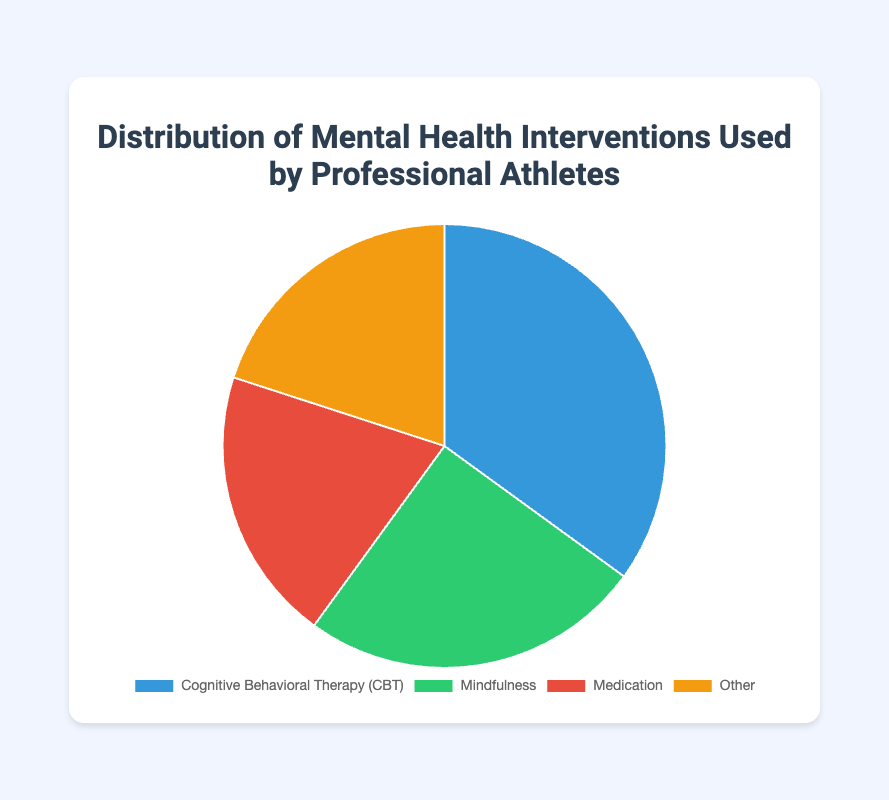Which mental health intervention is utilized the most by professional athletes? By looking at the pie chart, the Cognitive Behavioral Therapy (CBT) has the largest segment, representing the highest percentage of 35%.
Answer: Cognitive Behavioral Therapy (CBT) What percentage of mental health interventions are non-medication based? To find the non-medication-based interventions, sum the percentages of CBT (35%), Mindfulness (25%), and Other (20%): 35% + 25% + 20% = 80%.
Answer: 80% How does the usage of Medication compare to Other interventions? Both Medication and Other interventions each have a percentage of 20%. This means the usage of Medication is equal to Other interventions as per the pie chart.
Answer: Equal Which interventions combined constitute more than 50% of the total interventions? Adding the percentages of Cognitive Behavioral Therapy (CBT) at 35% and Mindfulness at 25% gives 35% + 25% = 60%, which is greater than 50%.
Answer: Cognitive Behavioral Therapy (CBT) and Mindfulness By what percentage does Mindfulness exceed Medication in usage? Subtract the percentage of Medication (20%) from the percentage of Mindfulness (25%): 25% - 20% = 5%. Mindfulness exceeds Medication by 5%.
Answer: 5% What is the color of the segment representing Mindfulness on the pie chart? The Mindfulness segment is represented in green as shown in the chart.
Answer: Green If we combine the percentages of Medication and CBT, what percentage of the total interventions does this represent? Sum the percentages of Medication (20%) and CBT (35%): 20% + 35% = 55%.
Answer: 55% Which segment has an equal percentage as the Medication segment? The Other segment has the same percentage (20%) as the Medication segment as indicated in the pie chart.
Answer: Other What is the sum of the interventions labeled Other, Medication, and Mindfulness? Adding the percentages of Other (20%), Medication (20%), and Mindfulness (25%): 20% + 20% + 25% = 65%.
Answer: 65% What proportion of the chart does the largest category occupy? The largest category, represented by CBT, occupies 35% of the chart.
Answer: 35% 